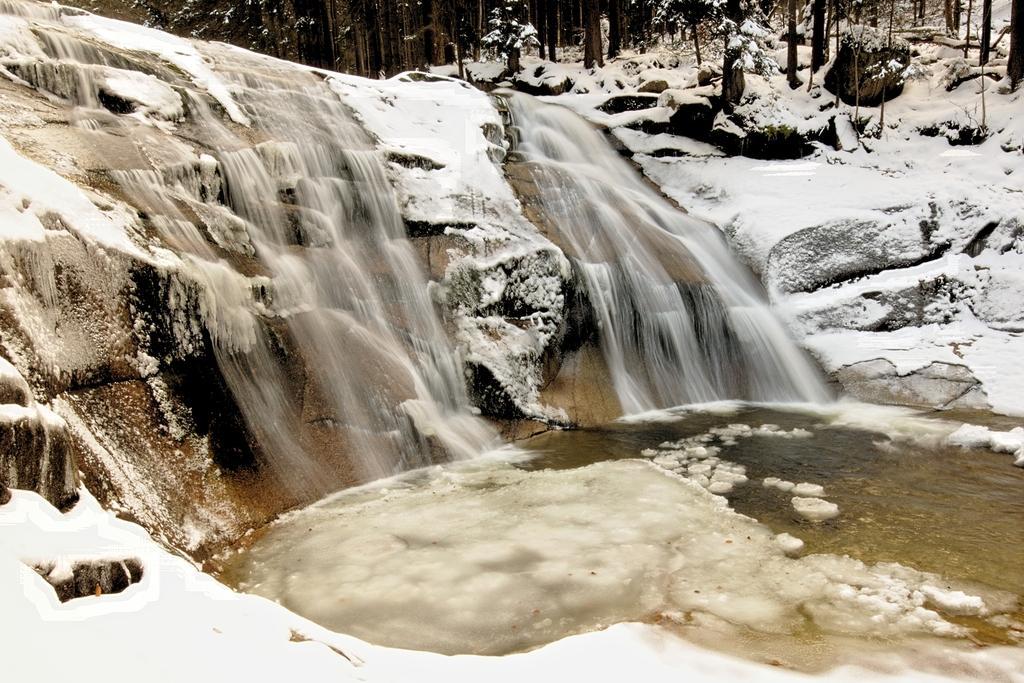How would you summarize this image in a sentence or two? In this image there is a waterfall, snow and trees. 